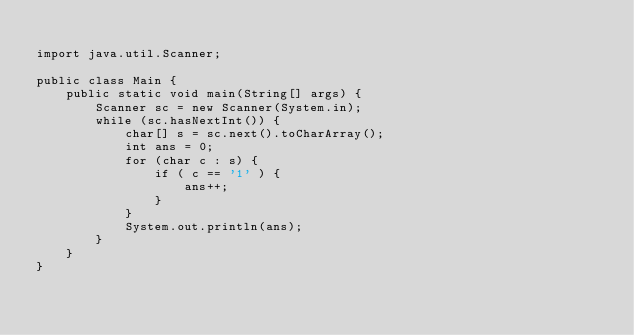<code> <loc_0><loc_0><loc_500><loc_500><_Java_>
import java.util.Scanner;

public class Main {
    public static void main(String[] args) {
        Scanner sc = new Scanner(System.in);
        while (sc.hasNextInt()) {
            char[] s = sc.next().toCharArray();
            int ans = 0;
            for (char c : s) {
                if ( c == '1' ) {
                    ans++;
                }
            }
            System.out.println(ans);
        }
    }
}
</code> 